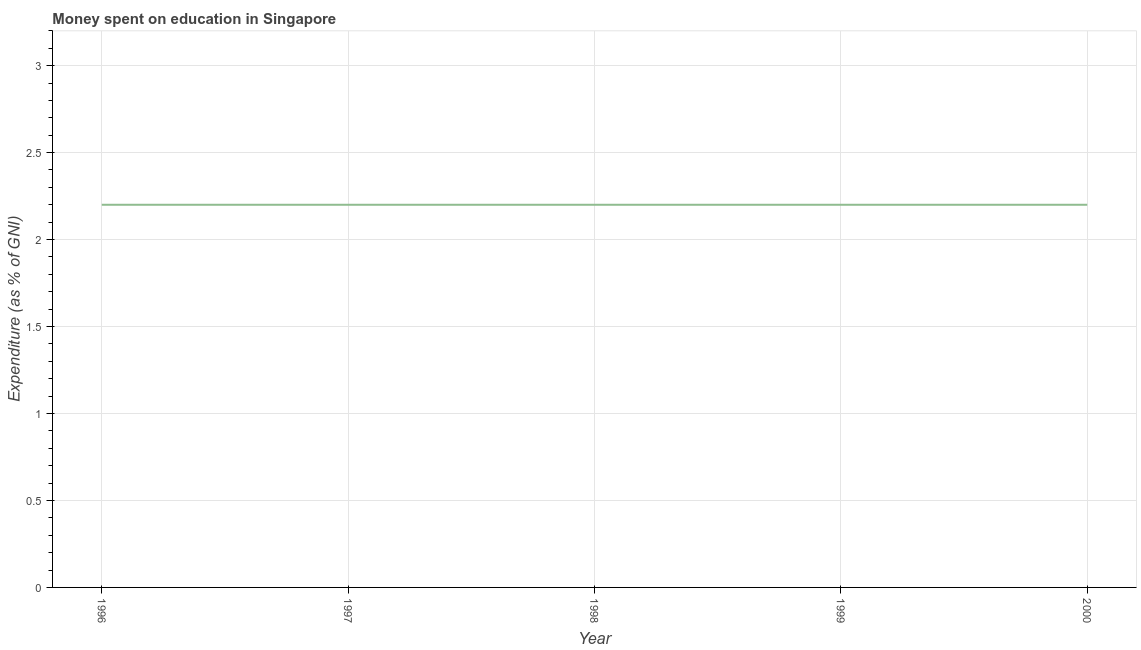What is the expenditure on education in 1998?
Your answer should be very brief. 2.2. Across all years, what is the maximum expenditure on education?
Your answer should be very brief. 2.2. In which year was the expenditure on education maximum?
Provide a short and direct response. 1996. What is the difference between the expenditure on education in 1996 and 1997?
Make the answer very short. 0. What is the median expenditure on education?
Ensure brevity in your answer.  2.2. Do a majority of the years between 1998 and 2000 (inclusive) have expenditure on education greater than 2.2 %?
Your response must be concise. No. What is the ratio of the expenditure on education in 1999 to that in 2000?
Your response must be concise. 1. Is the sum of the expenditure on education in 1996 and 2000 greater than the maximum expenditure on education across all years?
Your response must be concise. Yes. What is the difference between the highest and the lowest expenditure on education?
Your answer should be very brief. 0. In how many years, is the expenditure on education greater than the average expenditure on education taken over all years?
Provide a short and direct response. 0. How many lines are there?
Give a very brief answer. 1. How many years are there in the graph?
Give a very brief answer. 5. What is the title of the graph?
Your answer should be compact. Money spent on education in Singapore. What is the label or title of the Y-axis?
Your response must be concise. Expenditure (as % of GNI). What is the Expenditure (as % of GNI) in 1998?
Your response must be concise. 2.2. What is the Expenditure (as % of GNI) in 2000?
Offer a terse response. 2.2. What is the difference between the Expenditure (as % of GNI) in 1996 and 1998?
Make the answer very short. 0. What is the difference between the Expenditure (as % of GNI) in 1996 and 2000?
Ensure brevity in your answer.  0. What is the difference between the Expenditure (as % of GNI) in 1997 and 1998?
Offer a terse response. 0. What is the difference between the Expenditure (as % of GNI) in 1997 and 2000?
Keep it short and to the point. 0. What is the ratio of the Expenditure (as % of GNI) in 1997 to that in 2000?
Offer a very short reply. 1. What is the ratio of the Expenditure (as % of GNI) in 1998 to that in 1999?
Make the answer very short. 1. What is the ratio of the Expenditure (as % of GNI) in 1998 to that in 2000?
Your answer should be compact. 1. 